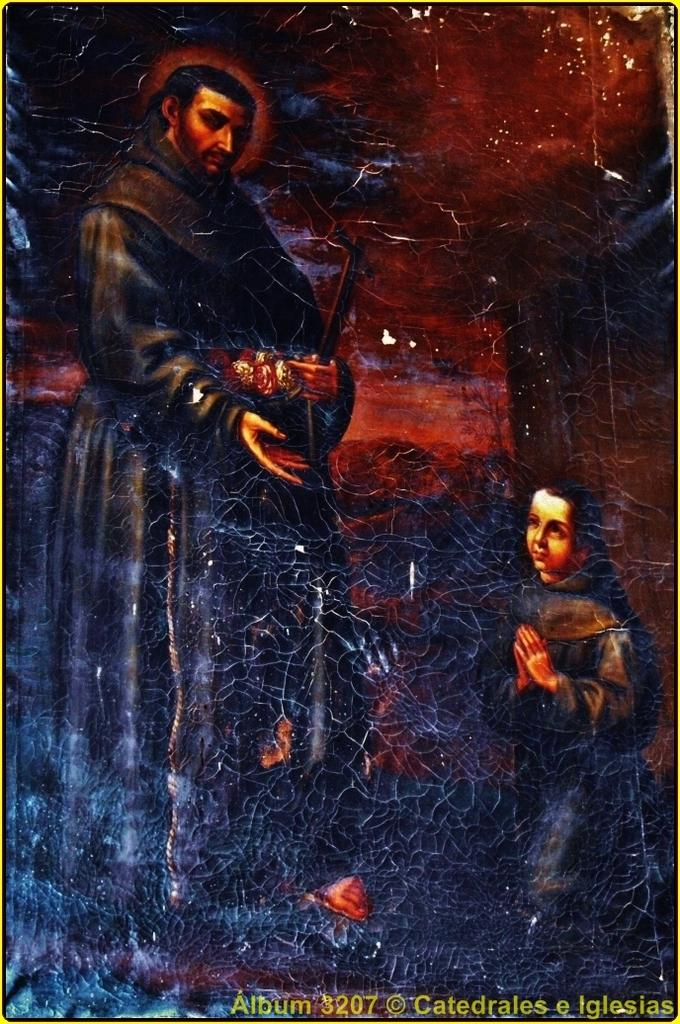<image>
Offer a succinct explanation of the picture presented. A painting is identified as Album 3207, Catedrales e Iglesias. 